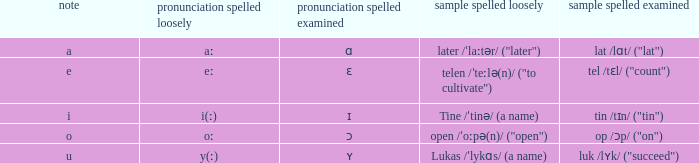What is Letter, when Example Spelled Checked is "tin /tɪn/ ("tin")"? I. 